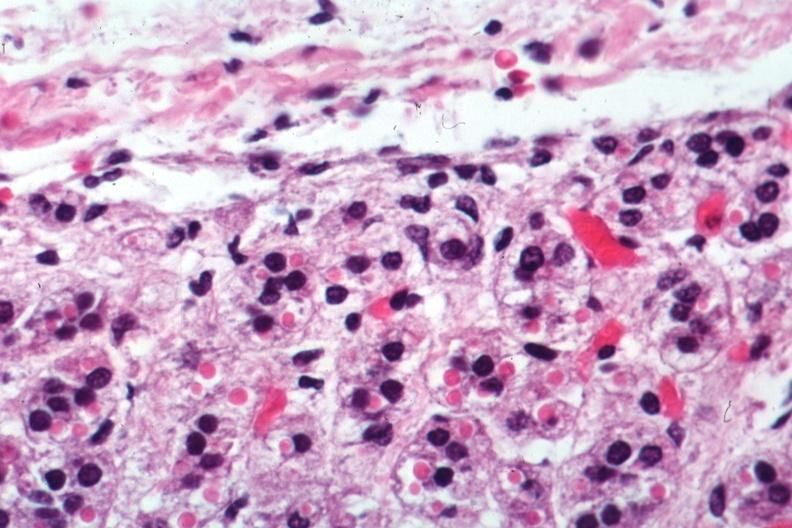s adrenal present?
Answer the question using a single word or phrase. Yes 